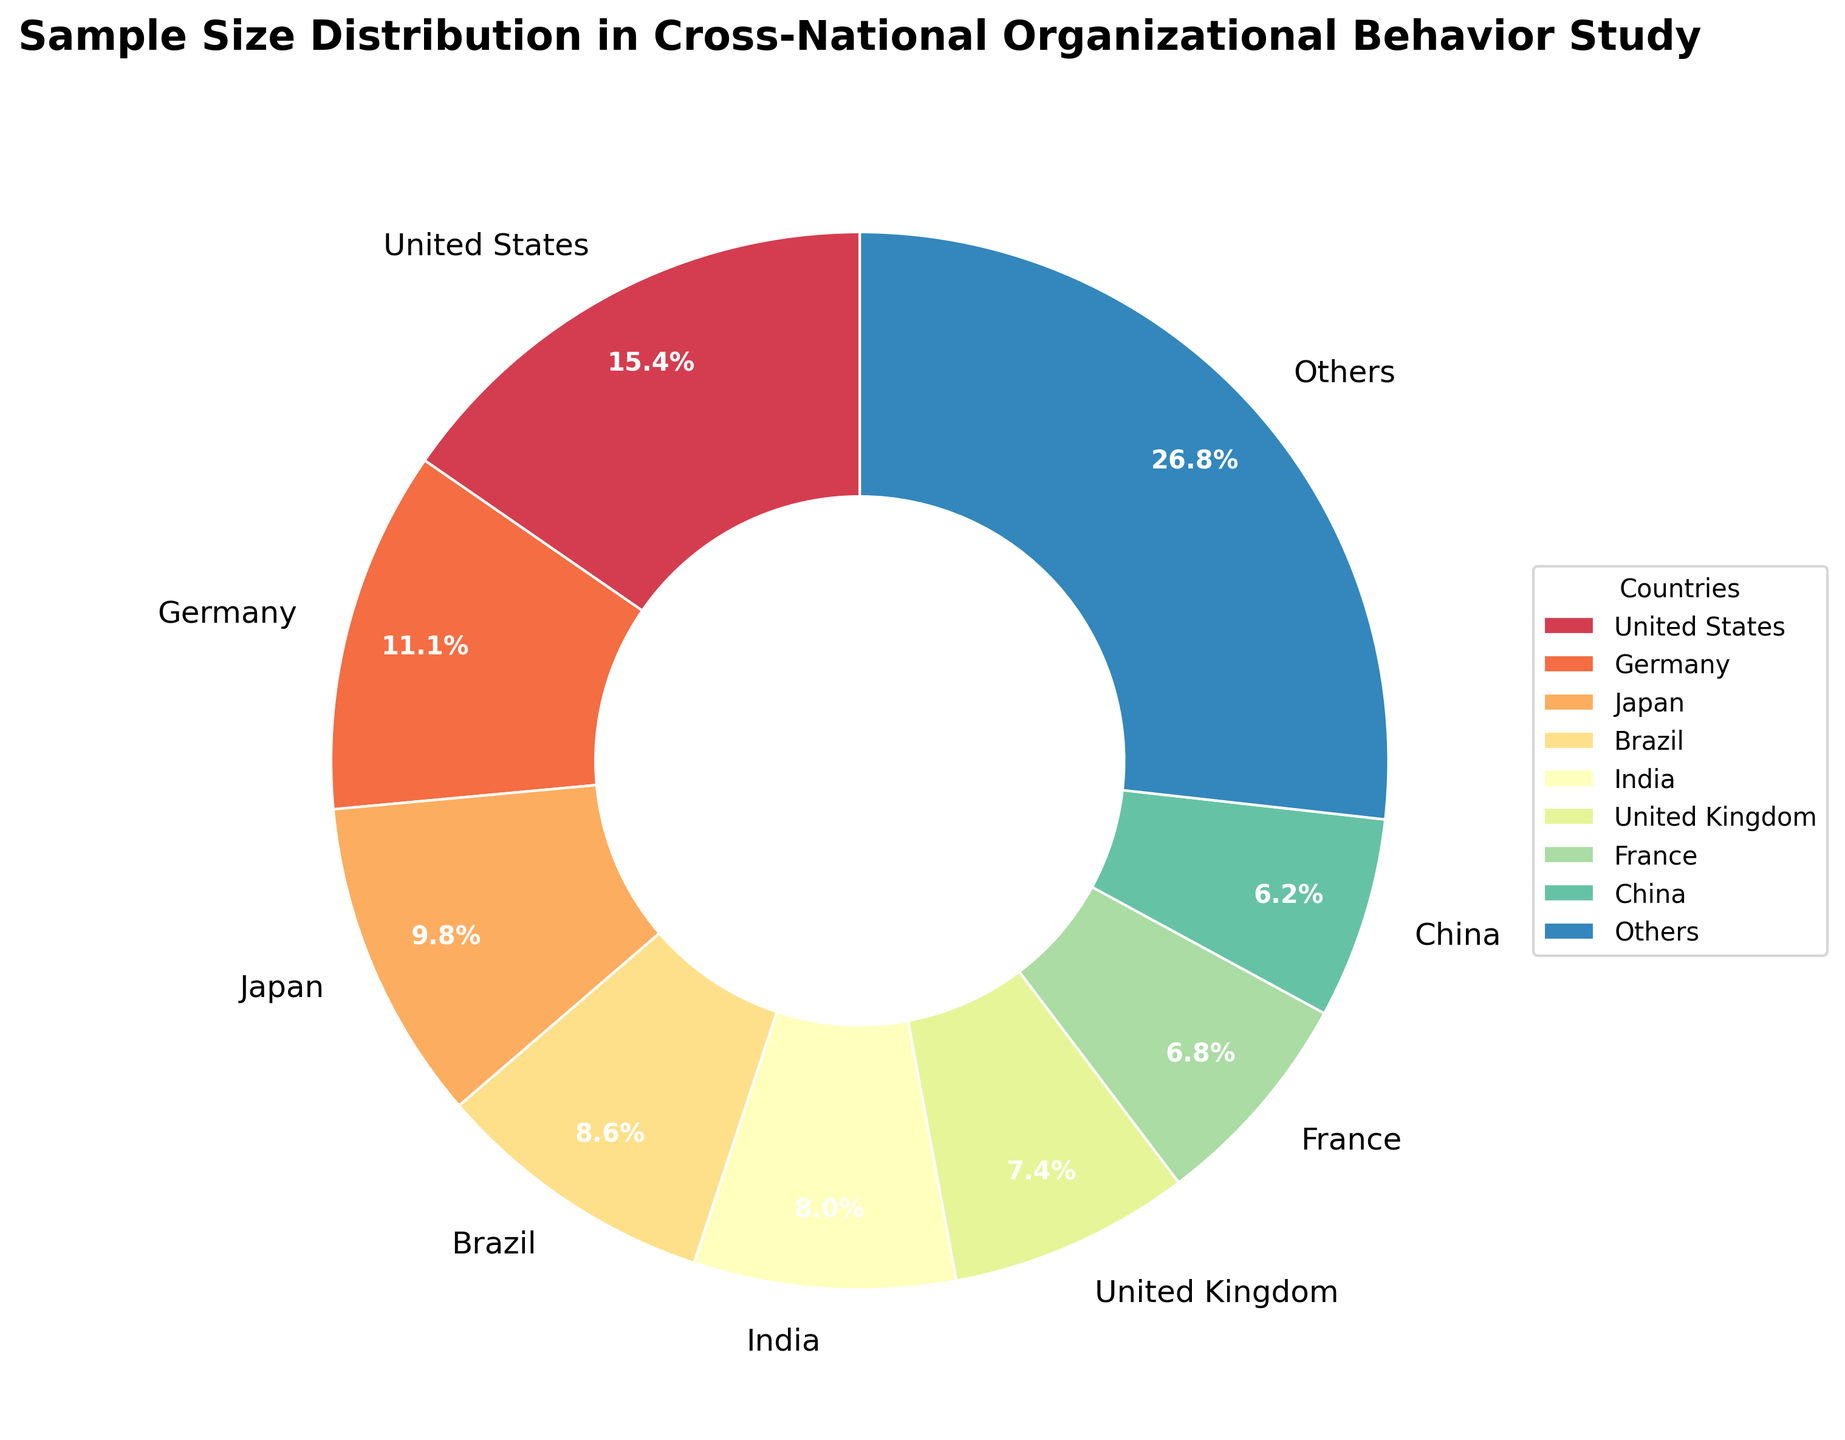What percentage of the sample size does the United States represent? The United States' percentage is displayed directly on the pie chart as part of the visual. Find the label for the United States wedge and read the percentage value.
Answer: 17.7% Which country has the smallest sample size and what percentage does it represent? Look for the smallest wedge in the pie chart, which corresponds to the smallest sample size, and read the label to find the country and its percentage.
Answer: Sweden, 2.8% What is the combined sample size percentage of Germany, Japan, and Brazil? Identify the percentages of Germany, Japan, and Brazil from the pie chart, then add these values: Germany (12.8%) + Japan (11.4%) + Brazil (10.0%).
Answer: 34.2% How does the sample size percentage of the United States compare to that of India and the United Kingdom combined? Find the percentage for the United States and the combined percentage of India and the United Kingdom. Compare the values: United States (17.7%) vs. India (9.2%) + United Kingdom (8.5%) = 17.7%.
Answer: Equal What is the visual attribute used to distinguish different countries on the pie chart? Determine the distinguishing feature used for different segments in the pie chart.
Answer: Color What percentage of the countries fall under the "Others" category? Sum the percentages of the segments labeled under "Others" by identifying the percentage provided for "Others" in the pie chart.
Answer: 22.1% What are the top three countries with the highest sample sizes? Identify the top three largest wedges in the pie chart, then read the labels to determine the countries.
Answer: United States, Germany, Japan How does the sample size percentage of France compare to that of Australia? Look at the percentages of France and Australia in the pie chart and compare them. France (7.8%) vs. Australia (5.7%).
Answer: France is greater What percentage of the total sample size is represented by Canada? Identify the percentage for Canada noted in the pie chart.
Answer: 6.4% What is the visual representation method used to depict the sample sizes of different countries in this pie chart? Describe the method used in the pie chart to visually represent the data.
Answer: Segmentation and color bands 